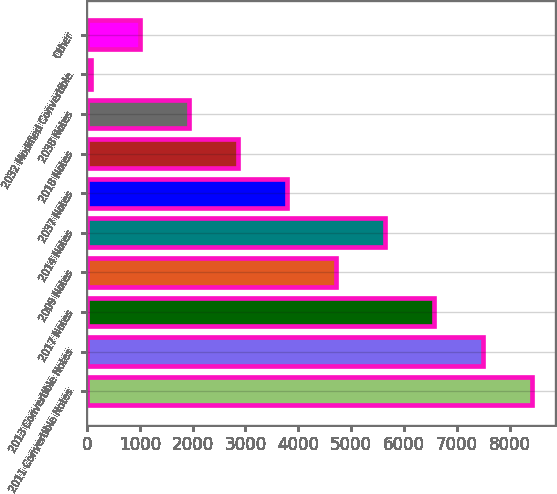<chart> <loc_0><loc_0><loc_500><loc_500><bar_chart><fcel>2011 Convertible Notes<fcel>2013 Convertible Notes<fcel>2017 Notes<fcel>2009 Notes<fcel>2014 Notes<fcel>2037 Notes<fcel>2018 Notes<fcel>2038 Notes<fcel>2032 Modified Convertible<fcel>Other<nl><fcel>8424.9<fcel>7497.8<fcel>6570.7<fcel>4716.5<fcel>5643.6<fcel>3789.4<fcel>2862.3<fcel>1935.2<fcel>81<fcel>1008.1<nl></chart> 